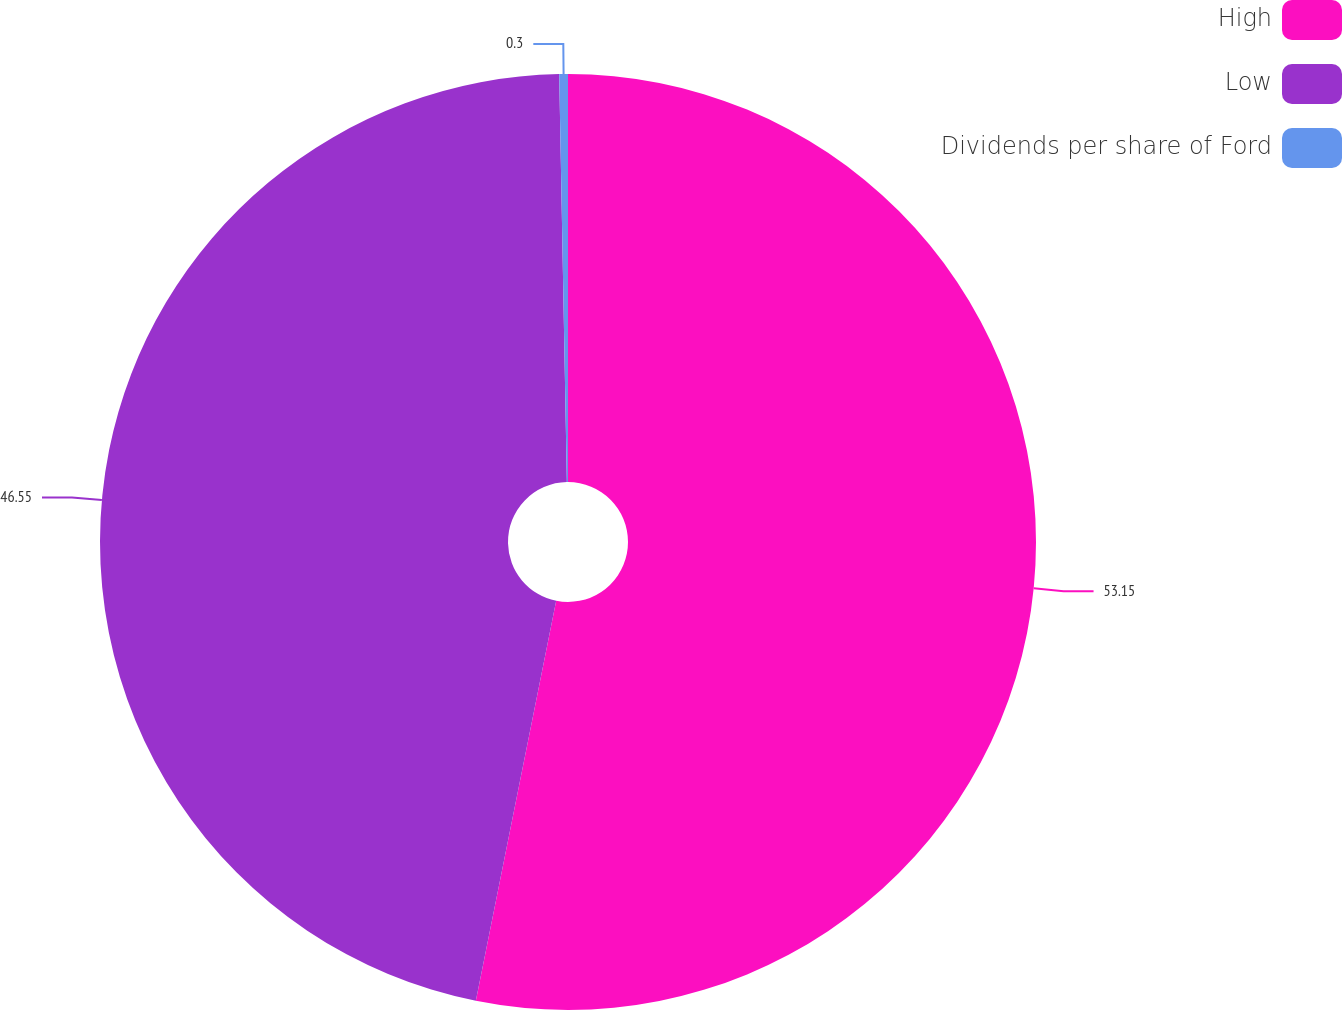<chart> <loc_0><loc_0><loc_500><loc_500><pie_chart><fcel>High<fcel>Low<fcel>Dividends per share of Ford<nl><fcel>53.16%<fcel>46.55%<fcel>0.3%<nl></chart> 